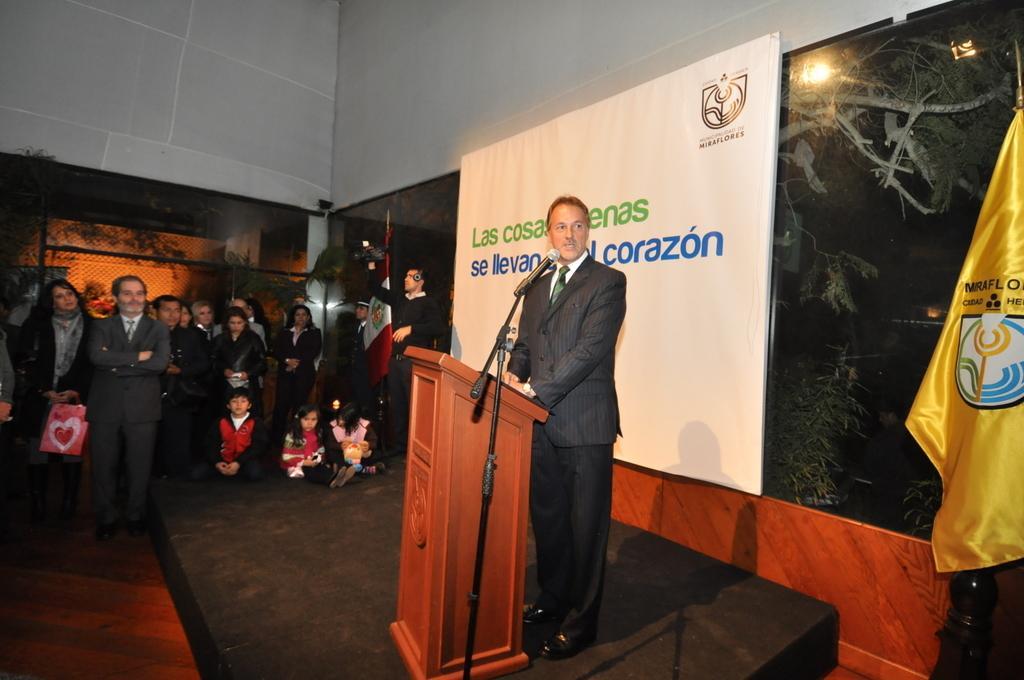How would you summarize this image in a sentence or two? In this picture we can see a person standing and talking in front of mike, side few people are standing, behind we can see a board to the wall and we can see flag. 